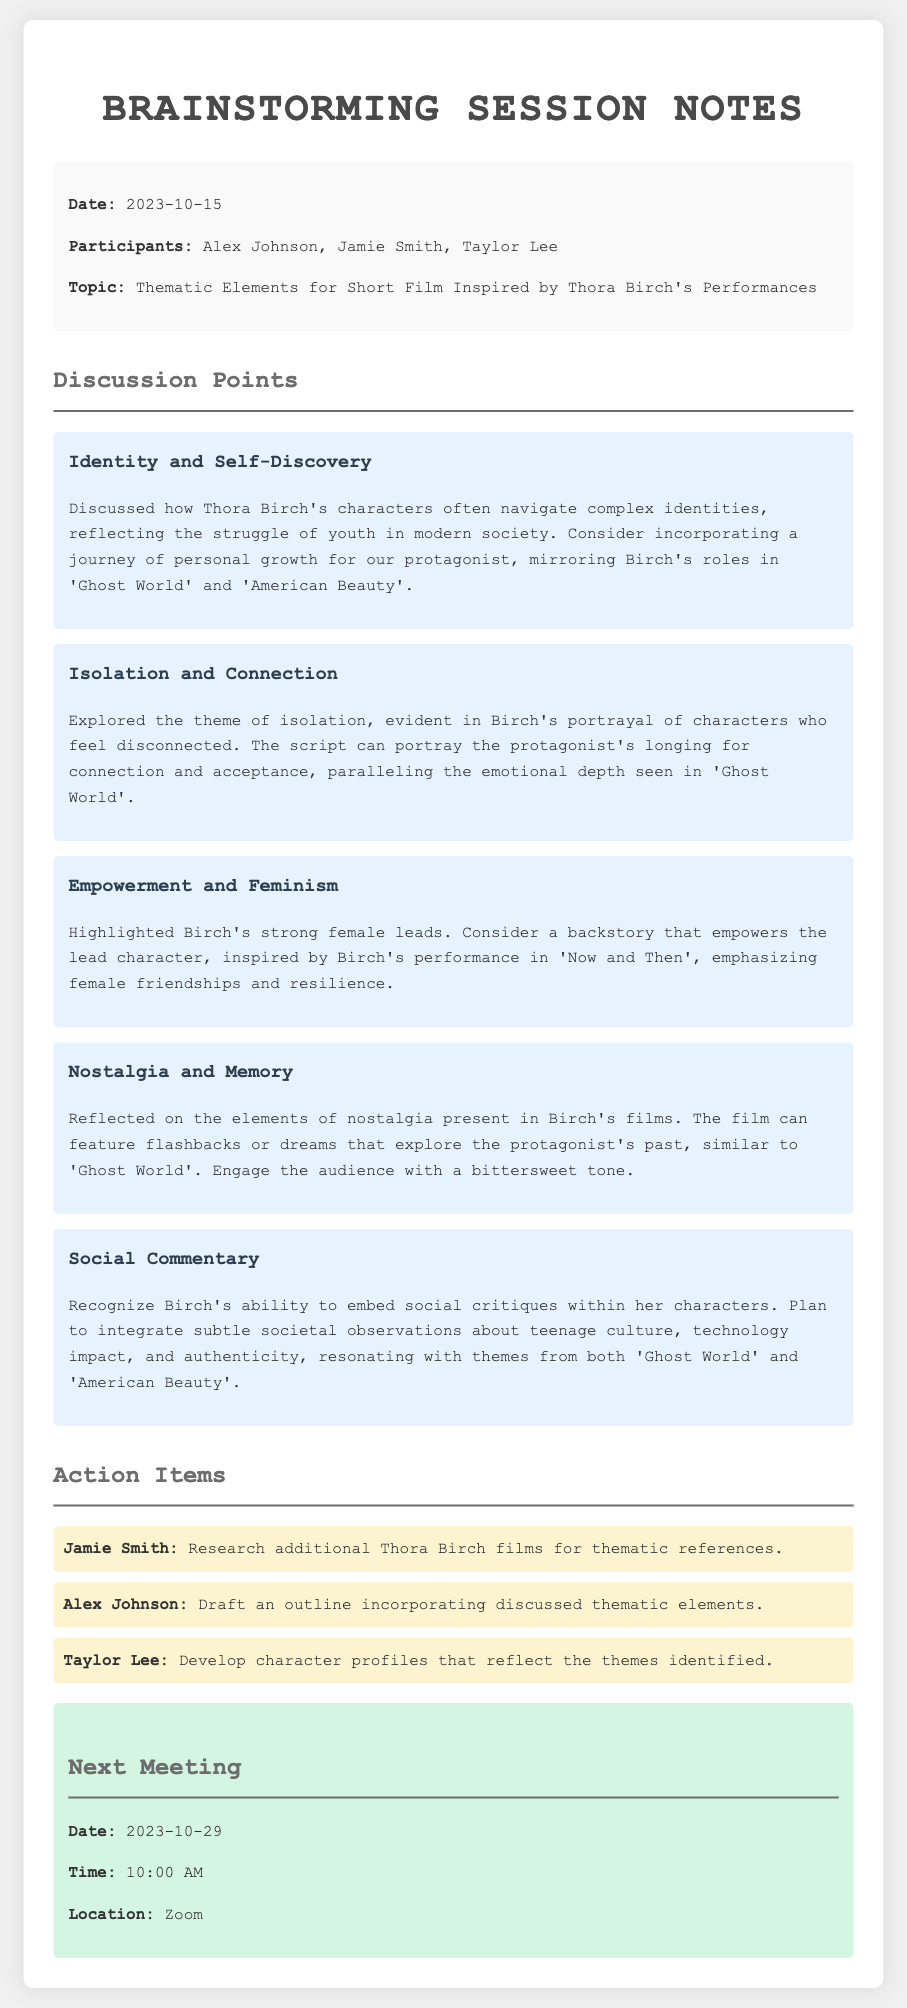what is the date of the brainstorming session? The date of the brainstorming session is listed in the document.
Answer: 2023-10-15 who are the participants in the session? The document lists the names of the participants involved in the session.
Answer: Alex Johnson, Jamie Smith, Taylor Lee what is one thematic element discussed in the session? The document outlines several thematic elements that were discussed.
Answer: Identity and Self-Discovery what is the next meeting date? The document specifies the date for the next meeting.
Answer: 2023-10-29 who is responsible for drafting an outline? The action items in the document assign specific tasks to the participants.
Answer: Alex Johnson which film was mentioned as an inspiration for the themes? The document references specific films to highlight thematic elements.
Answer: Ghost World 